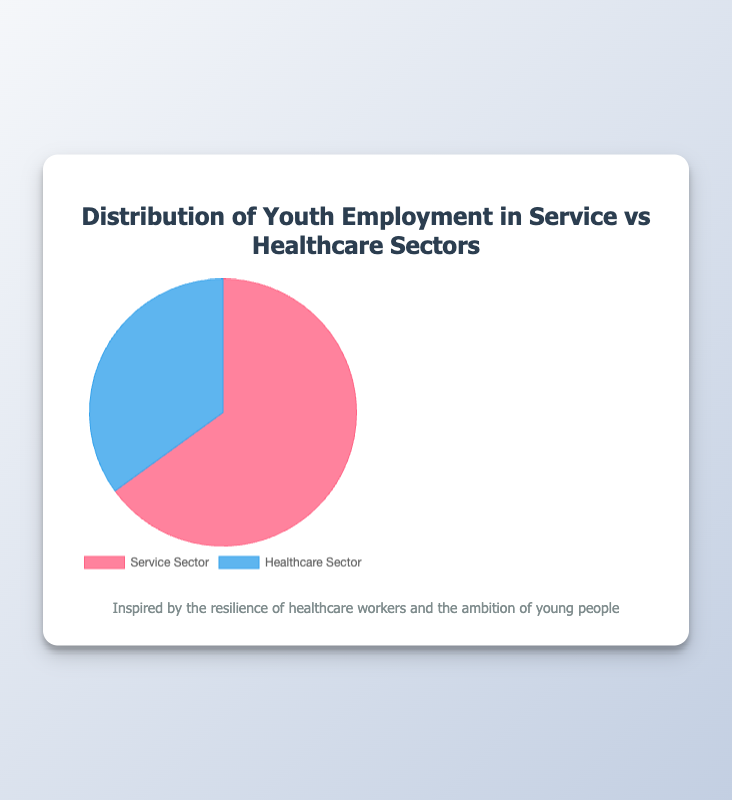What percentage of youth employment is in the service sector? The pie chart displays the percentage distribution with 65% allocated to the Service Sector.
Answer: 65% What percentage of youth employment is in the healthcare sector? The chart shows 35% of youth employment is in the Healthcare Sector, as indicated by the pie slice and legend.
Answer: 35% Are more youths employed in the service sector or the healthcare sector? Comparing the two sectors, the chart shows 65% of youths are employed in the Service Sector, which is greater than the 35% in the Healthcare Sector.
Answer: Service Sector What is the difference in youth employment percentages between the service and healthcare sectors? The difference can be calculated by subtracting the healthcare sector percentage (35%) from the service sector percentage (65%): 65% - 35% = 30%.
Answer: 30% If there are 10,000 youths employed, how many work in the service sector? To find out the number of youths in the service sector, multiply 10,000 by 65%: 10,000 * 0.65 = 6,500.
Answer: 6,500 What percentage of youth employment is in sectors other than healthcare? Since healthcare accounts for 35%, the remaining percentage is 100% - 35% = 65%, all of which is in the service sector according to the pie chart.
Answer: 65% If the total youth employment increases by 1,000, how does this affect the number of youths in the healthcare sector? Firstly, calculate the initial number of youths in healthcare for a hypothetical total of 10,000: 10,000 * 0.35 = 3,500. With an increase, the new total is 11,000. Therefore, 11,000 * 0.35 = 3,850. The effect is then 3,850 - 3,500 = 350.
Answer: 350 more What is the ratio of youth employment in the service sector to the healthcare sector? The ratio can be found by dividing the percentages: 65% / 35%. Simplifying this ratio results in approximately 1.857, or roughly 1.86 (to two decimal places).
Answer: 1.86 Visually, which sector has a larger portion of the pie chart, and by how much? The Service Sector occupies a larger portion of the pie chart. Visually, this larger portion amounts to the difference between 65% (service) and 35% (healthcare), which is 30%.
Answer: Service Sector, by 30% If the percentage of healthcare sector employment doubled, what would be the new distribution? Doubling the healthcare sector percentage: 35% * 2 = 70%. Assuming no changes in the total, the service sector would then drop to 100% - 70% = 30%.
Answer: Service Sector: 30%, Healthcare Sector: 70% 